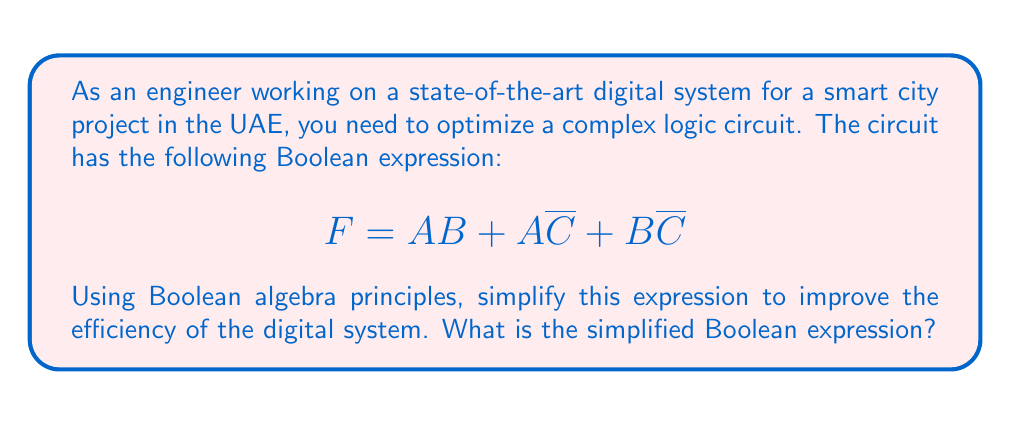Solve this math problem. To simplify the given Boolean expression, we'll use Boolean algebra laws and theorems. Let's approach this step-by-step:

1) Start with the given expression:
   $$F = AB + A\overline{C} + B\overline{C}$$

2) Apply the distributive law to factor out common terms:
   $$F = AB + \overline{C}(A + B)$$

3) Now, we can use the absorption law, which states that $X + XY = X$. In our case:
   Let $X = A + B$ and $Y = \overline{C}$
   
   $$(A + B) + (A + B)\overline{C} = A + B$$

4) Therefore, our expression becomes:
   $$F = A + B$$

This simplified expression reduces the number of terms from three to two, and eliminates the need for the $\overline{C}$ term altogether. This simplification will lead to a more efficient digital system, requiring fewer logic gates and potentially reducing power consumption and propagation delay.
Answer: $F = A + B$ 